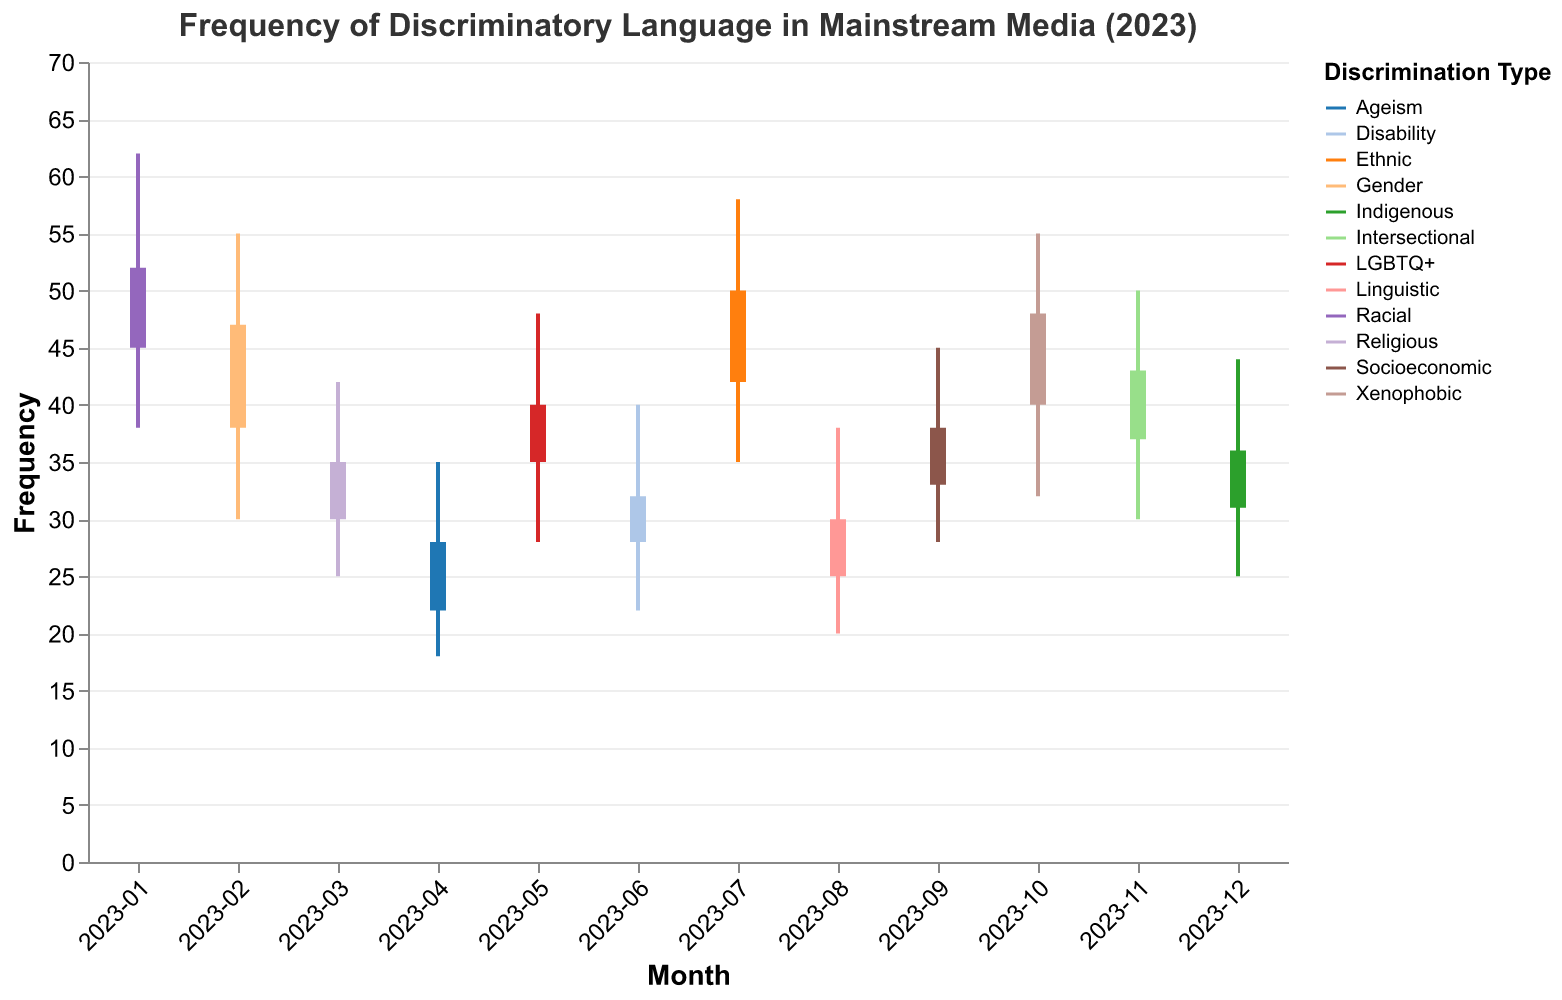What's the title of the chart? The title is displayed at the top of the chart and provides an overview of what the chart is about.
Answer: Frequency of Discriminatory Language in Mainstream Media (2023) How many different types of discrimination are covered in the chart? Each type of discrimination is labeled with a unique color on the chart.
Answer: 12 Which type of discrimination had the highest frequency in any month? By finding the highest "High" value, we can identify the type. For "Racial" in January, the high was 62, which is the maximum.
Answer: Racial In which month did "Linguistic" discrimination peak? Locate the "High" value for "Linguistic" in each month. August shows a high of 38.
Answer: August What was the frequency range (Low to High) of "Gender" discrimination in February? Verify the "Low" and "High" values for "Gender" in February. The Low was 30 and the High was 55.
Answer: 30 to 55 Compare the closing frequency of "Ethnic" discrimination in July to "Xenophobic" discrimination in October. Check the "Close" values for both "Ethnic" in July (50) and "Xenophobic" in October (48). "Ethnic" is higher.
Answer: The closing frequency for "Ethnic" discrimination in July was higher What is the smallest closing frequency recorded, and which type of discrimination does it correspond to? Identify the lowest "Close" value across all types and months. "Ageism" in April had the smallest close value of 28.
Answer: 28, Ageism What was the most substantial increase in frequency from opening to closing value in any month? Calculate the difference between "Close" and "Open" values for each entry. The highest is for "Linguistic" in August, which rose from 25 to 30, an increase of 5.
Answer: Linguistic, August How does the range of "Disability" in June compare to the range of "Socioeconomic" in September? For "Disability" in June, the range is 18 (40-22). For "Socioeconomic" in September, it's 17 (45-28). The range for "Disability" is slightly larger.
Answer: The range for "Disability" in June is larger Which month had the highest overall frequency of discriminatory language, and what was its value? Look for the highest "High" value among all months. "Racial" in January had the highest overall frequency with a value of 62.
Answer: January, 62 